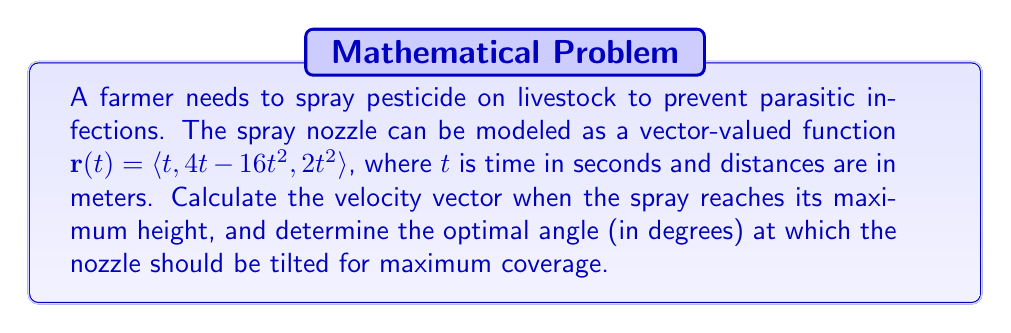Solve this math problem. To solve this problem, we'll follow these steps:

1) First, we need to find when the spray reaches its maximum height. The height is given by the y-component of $\mathbf{r}(t)$: $y(t) = 4t - 16t^2$.

2) To find the maximum height, we differentiate y(t) and set it to zero:
   $$\frac{dy}{dt} = 4 - 32t = 0$$
   $$32t = 4$$
   $$t = \frac{1}{8}$$

3) Now we can calculate the velocity vector at this time. The velocity vector is the derivative of the position vector:
   $$\mathbf{v}(t) = \mathbf{r}'(t) = \langle 1, 4 - 32t, 4t \rangle$$

   At $t = \frac{1}{8}$:
   $$\mathbf{v}(\frac{1}{8}) = \langle 1, 4 - 32(\frac{1}{8}), 4(\frac{1}{8}) \rangle = \langle 1, 0, \frac{1}{2} \rangle$$

4) To find the optimal angle, we need to calculate the angle this velocity vector makes with the horizontal. We can use the arctangent function:
   $$\theta = \arctan(\frac{v_z}{v_x}) = \arctan(\frac{1/2}{1}) = \arctan(0.5)$$

5) Convert this angle to degrees:
   $$\theta = \arctan(0.5) * \frac{180}{\pi} \approx 26.57°$$
Answer: The velocity vector when the spray reaches its maximum height is $\langle 1, 0, \frac{1}{2} \rangle$ m/s, and the optimal angle for the nozzle is approximately 26.57°. 